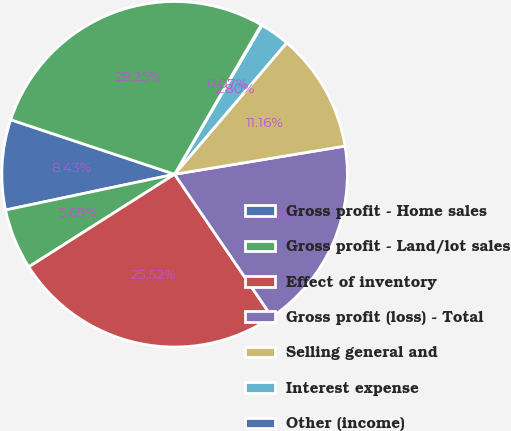<chart> <loc_0><loc_0><loc_500><loc_500><pie_chart><fcel>Gross profit - Home sales<fcel>Gross profit - Land/lot sales<fcel>Effect of inventory<fcel>Gross profit (loss) - Total<fcel>Selling general and<fcel>Interest expense<fcel>Other (income)<fcel>Loss before income taxes<nl><fcel>8.43%<fcel>5.69%<fcel>25.52%<fcel>18.08%<fcel>11.16%<fcel>2.8%<fcel>0.07%<fcel>28.25%<nl></chart> 